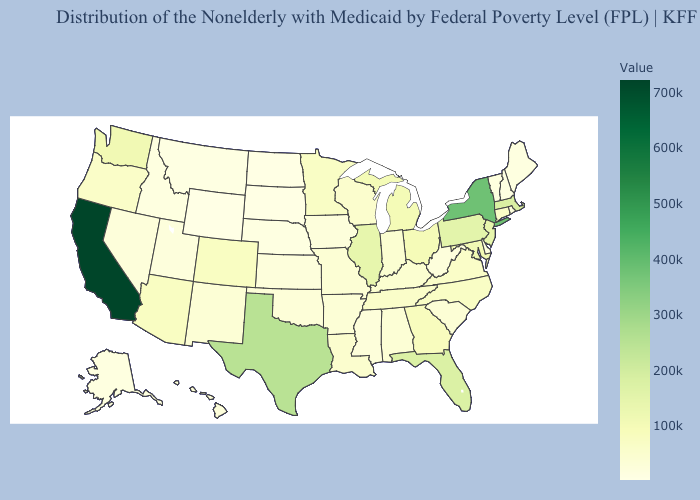Among the states that border Mississippi , does Louisiana have the highest value?
Short answer required. No. Does California have the highest value in the West?
Be succinct. Yes. Which states have the highest value in the USA?
Answer briefly. California. Is the legend a continuous bar?
Short answer required. Yes. Does Ohio have a higher value than Nevada?
Concise answer only. Yes. Is the legend a continuous bar?
Keep it brief. Yes. 